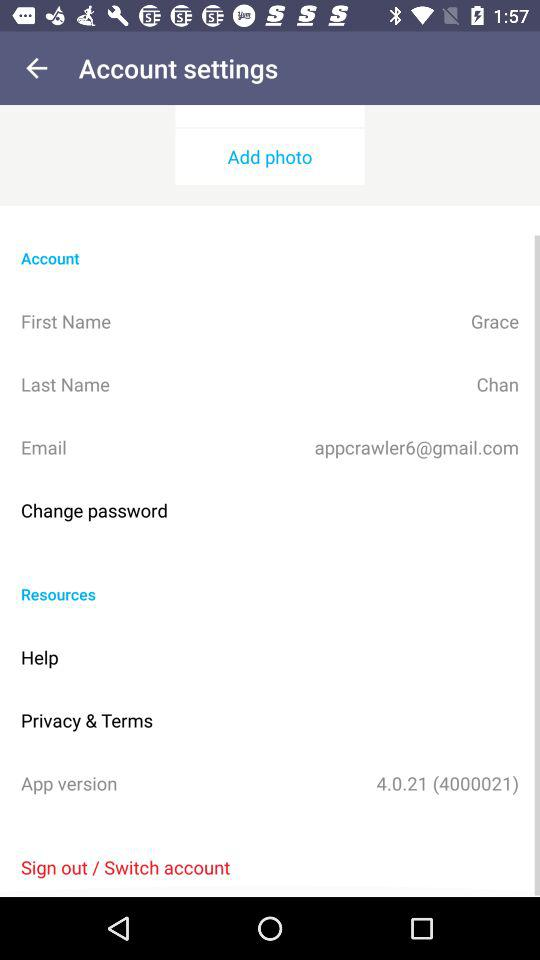What is the email address? The email address is appcrawler6@gmail.com. 